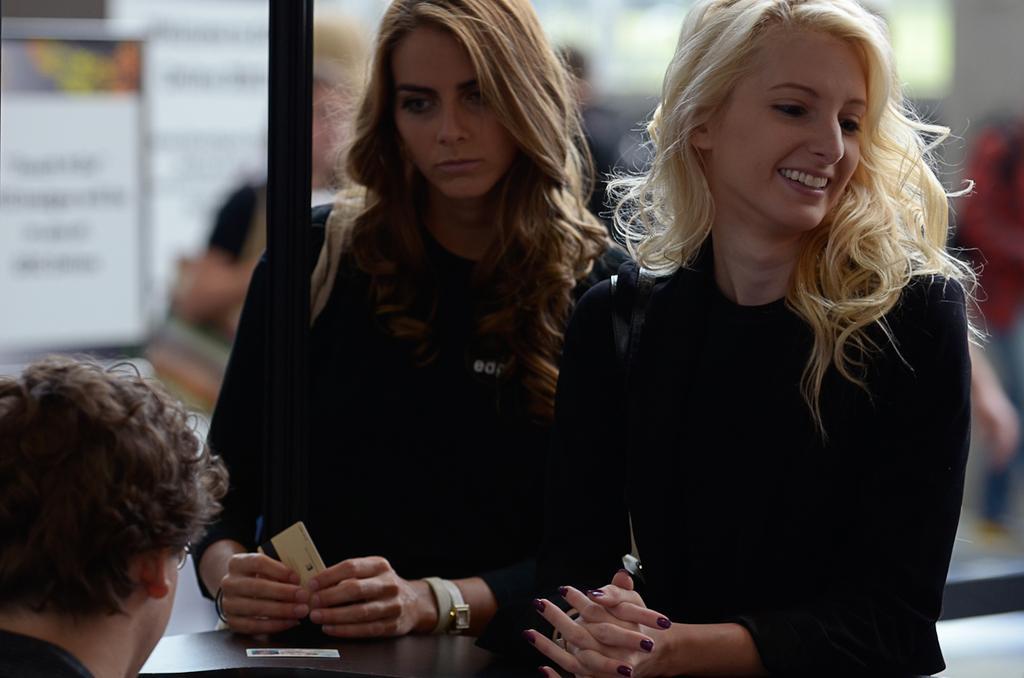In one or two sentences, can you explain what this image depicts? This picture consists of two woman visible in front of table , in the bottom left there is a person ,there is a pole in the middle , background there are might be group of persons visible 